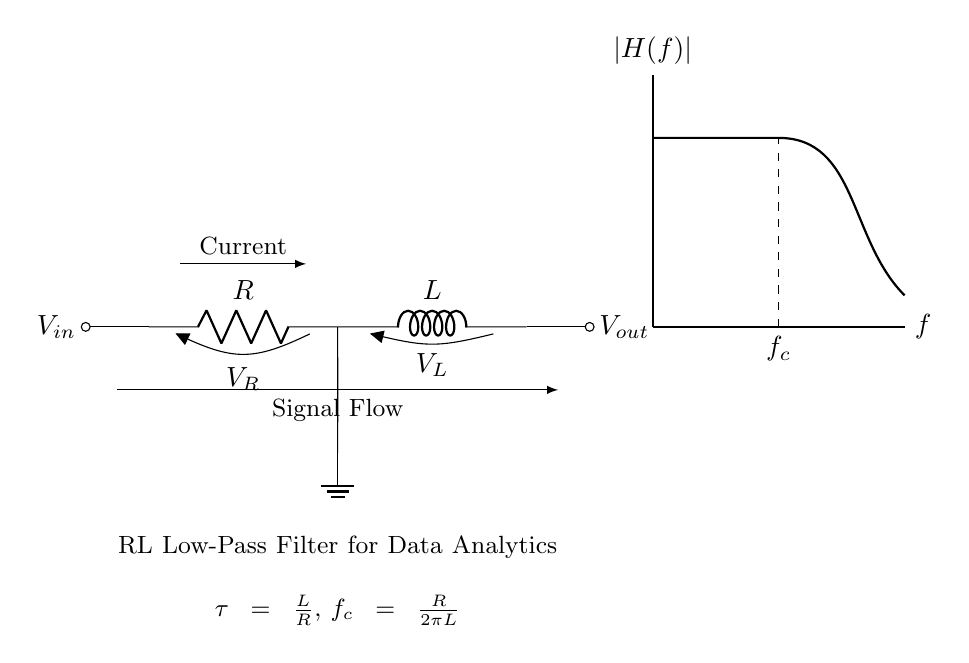What components are present in this circuit? The circuit contains a resistor and an inductor, which are clearly labeled as R and L respectively in the diagram.
Answer: Resistor, Inductor What does the term "tau" represent in this circuit? Tau is defined in the diagram as the time constant and is given by the ratio of inductance L to resistance R, indicating the time it takes for the current to change significantly.
Answer: Time constant What is the cutoff frequency for this RL filter? The cutoff frequency is provided in the diagram as f_c, calculated using the formula R divided by 2πL, indicating the frequency at which the output signal begins to attenuate.
Answer: R over 2πL What direction does the current flow in this circuit? The diagram shows an arrow indicating the direction of current flow, which moves from the input voltage source through the resistor and inductor before exiting.
Answer: Left to right What is the relationship between the voltage across the resistor and the inductor? The voltage across the resistor (V_R) is the drop caused by current, while the inductor (V_L) opposes changes in the current flow; both voltages add up to the input voltage. This relationship reflects Kirchhoff's voltage law.
Answer: V_R + V_L = V_in Why is this circuit considered a low-pass filter? This circuit is classified as a low-pass filter because it allows signals with a frequency below the cutoff frequency to pass through while attenuating higher frequencies due to the inductive reactance increasing with frequency.
Answer: Low-pass filter 